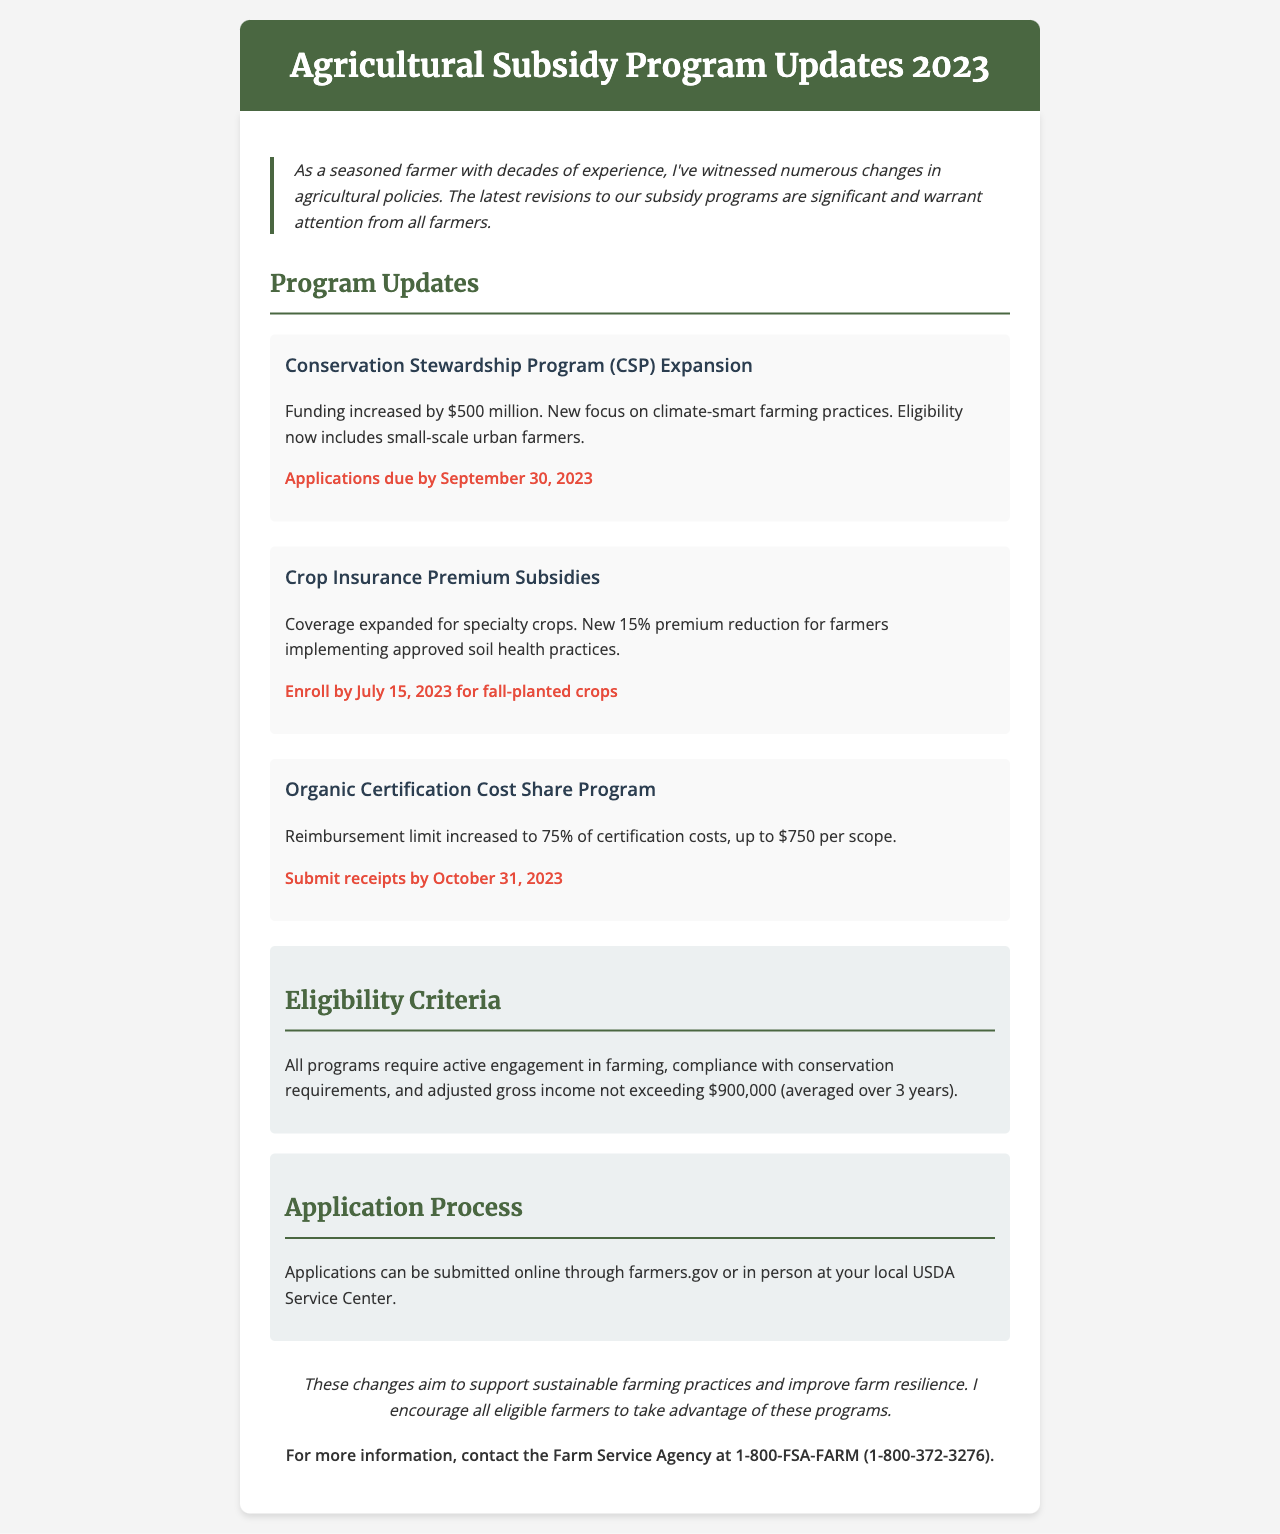What is the new funding amount for the Conservation Stewardship Program? The document states that the funding has increased by $500 million for the Conservation Stewardship Program.
Answer: $500 million When is the application deadline for the Conservation Stewardship Program? The document specifies that applications are due by September 30, 2023.
Answer: September 30, 2023 What percentage of reimbursement is now available for the Organic Certification Cost Share Program? The document mentions that the reimbursement limit has increased to 75% of certification costs.
Answer: 75% What income threshold must farmers not exceed to be eligible for the subsidy programs? The eligibility criteria indicate that the adjusted gross income must not exceed $900,000 (averaged over 3 years).
Answer: $900,000 What new premium reduction percentage is available for farmers implementing soil health practices? According to the document, there is a new 15% premium reduction for farmers implementing approved soil health practices.
Answer: 15% Where can applications be submitted for the subsidy programs? The document states that applications can be submitted online through farmers.gov or in person at the local USDA Service Center.
Answer: farmers.gov What is emphasized as the focus of the expanded Conservation Stewardship Program? The document highlights that the new focus is on climate-smart farming practices.
Answer: climate-smart farming practices What is the reimbursement limit for the Organic Certification Cost Share Program? The document indicates that the reimbursement limit is up to $750 per scope.
Answer: $750 